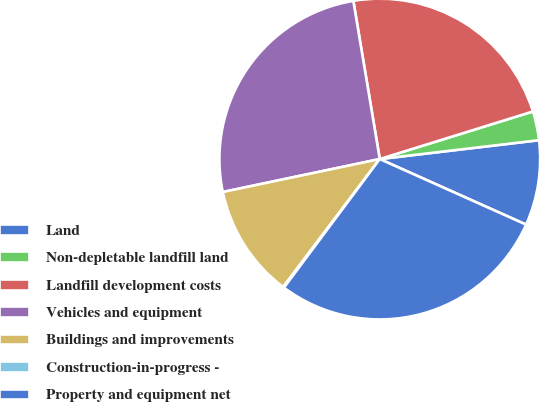<chart> <loc_0><loc_0><loc_500><loc_500><pie_chart><fcel>Land<fcel>Non-depletable landfill land<fcel>Landfill development costs<fcel>Vehicles and equipment<fcel>Buildings and improvements<fcel>Construction-in-progress -<fcel>Property and equipment net<nl><fcel>8.58%<fcel>2.92%<fcel>22.84%<fcel>25.66%<fcel>11.41%<fcel>0.1%<fcel>28.49%<nl></chart> 